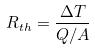Convert formula to latex. <formula><loc_0><loc_0><loc_500><loc_500>R _ { t h } = \frac { \Delta T } { Q / A }</formula> 